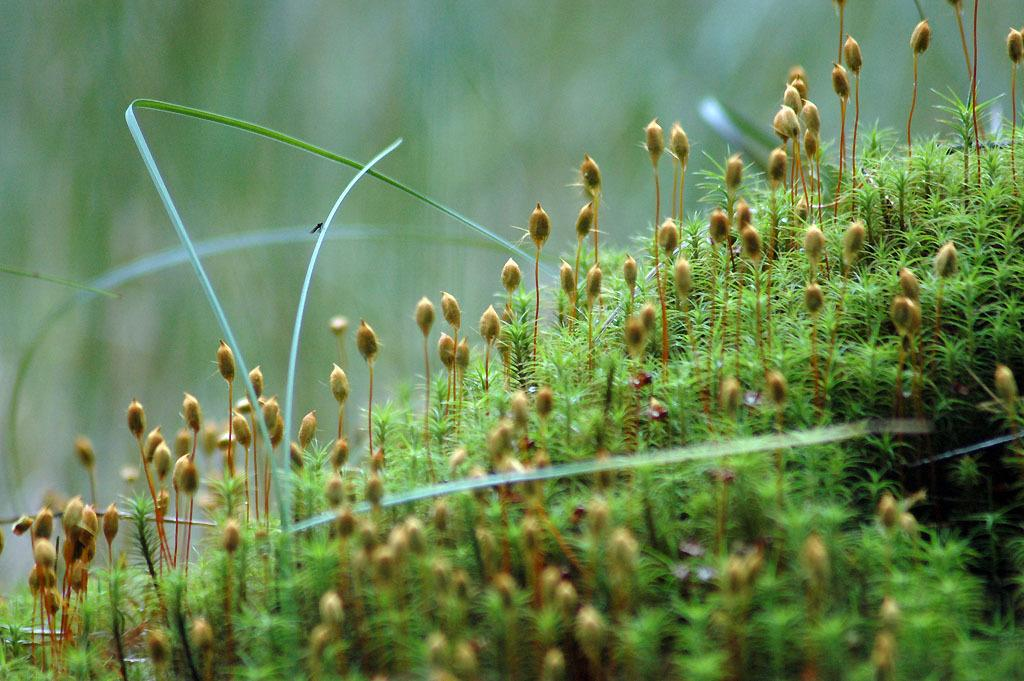What type of living organisms can be seen in the image? Plants can be seen in the image. Can you describe any specific interaction between the plants and other elements in the image? Yes, there is an insect on a plant in the image. How would you describe the overall appearance of the image? The background of the image is blurred. What role does the mother play in the image? There is no mention of a mother or any human presence in the image; it primarily features plants and an insect. 